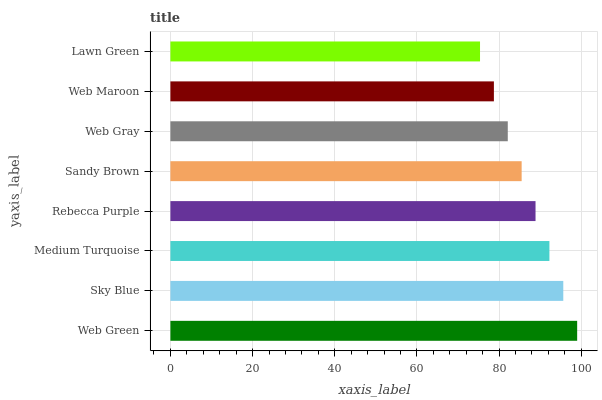Is Lawn Green the minimum?
Answer yes or no. Yes. Is Web Green the maximum?
Answer yes or no. Yes. Is Sky Blue the minimum?
Answer yes or no. No. Is Sky Blue the maximum?
Answer yes or no. No. Is Web Green greater than Sky Blue?
Answer yes or no. Yes. Is Sky Blue less than Web Green?
Answer yes or no. Yes. Is Sky Blue greater than Web Green?
Answer yes or no. No. Is Web Green less than Sky Blue?
Answer yes or no. No. Is Rebecca Purple the high median?
Answer yes or no. Yes. Is Sandy Brown the low median?
Answer yes or no. Yes. Is Sky Blue the high median?
Answer yes or no. No. Is Web Green the low median?
Answer yes or no. No. 